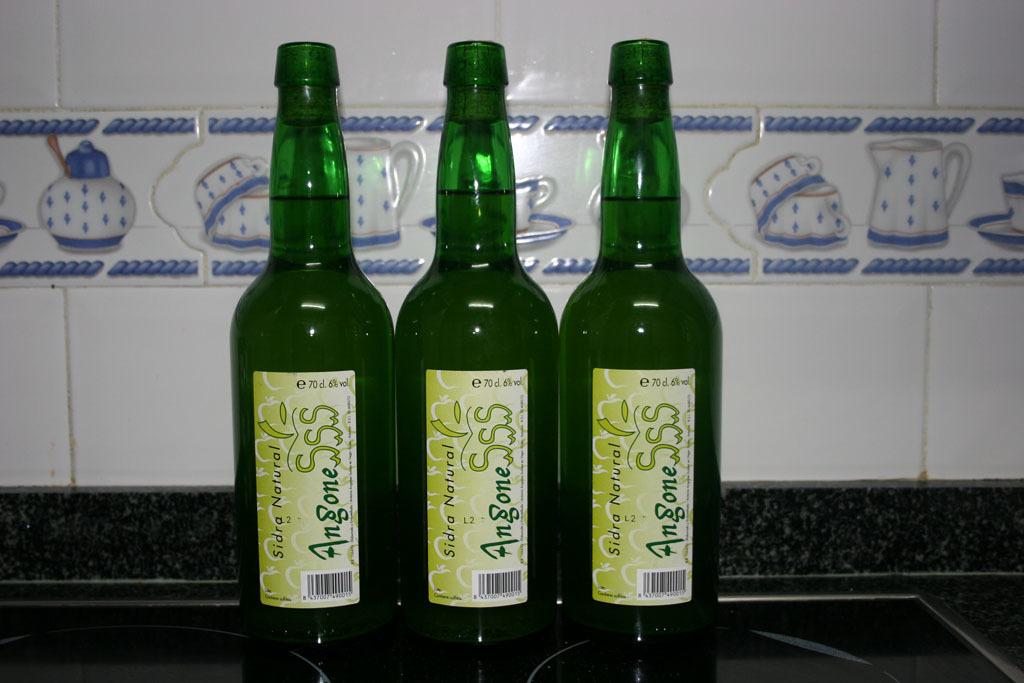What types of drinks are on the table?
Provide a succinct answer. Angone. What is the brand of drink?
Offer a terse response. Angone. 